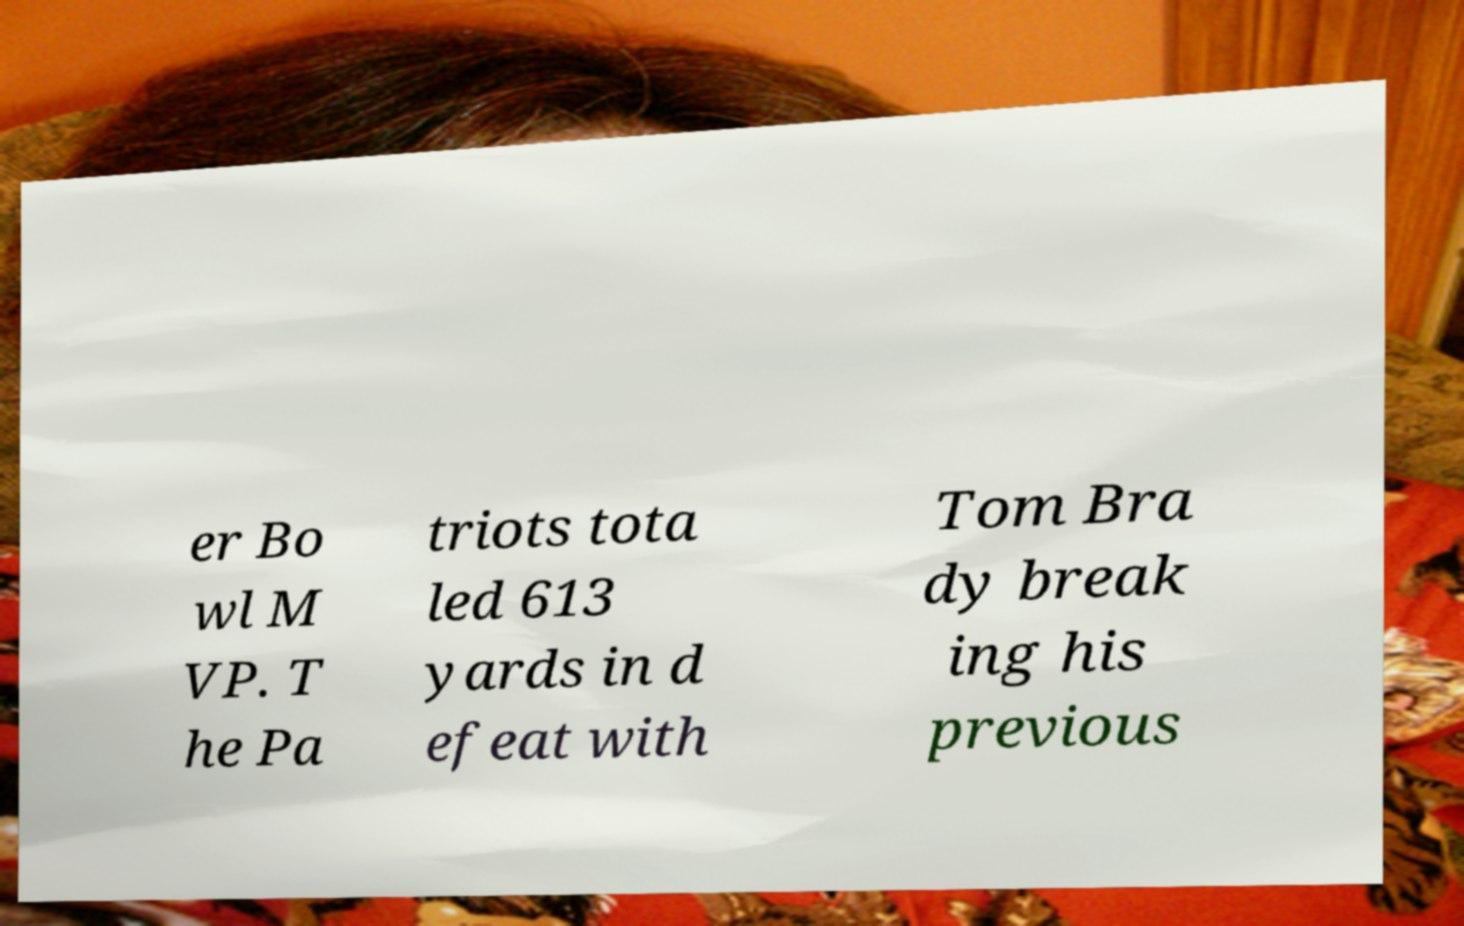Can you read and provide the text displayed in the image?This photo seems to have some interesting text. Can you extract and type it out for me? er Bo wl M VP. T he Pa triots tota led 613 yards in d efeat with Tom Bra dy break ing his previous 